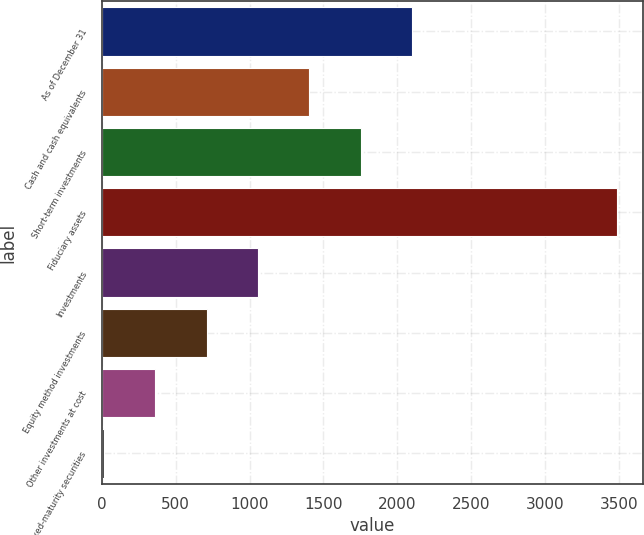<chart> <loc_0><loc_0><loc_500><loc_500><bar_chart><fcel>As of December 31<fcel>Cash and cash equivalents<fcel>Short-term investments<fcel>Fiduciary assets<fcel>Investments<fcel>Equity method investments<fcel>Other investments at cost<fcel>Fixed-maturity securities<nl><fcel>2099.4<fcel>1404.6<fcel>1752<fcel>3489<fcel>1057.2<fcel>709.8<fcel>362.4<fcel>15<nl></chart> 